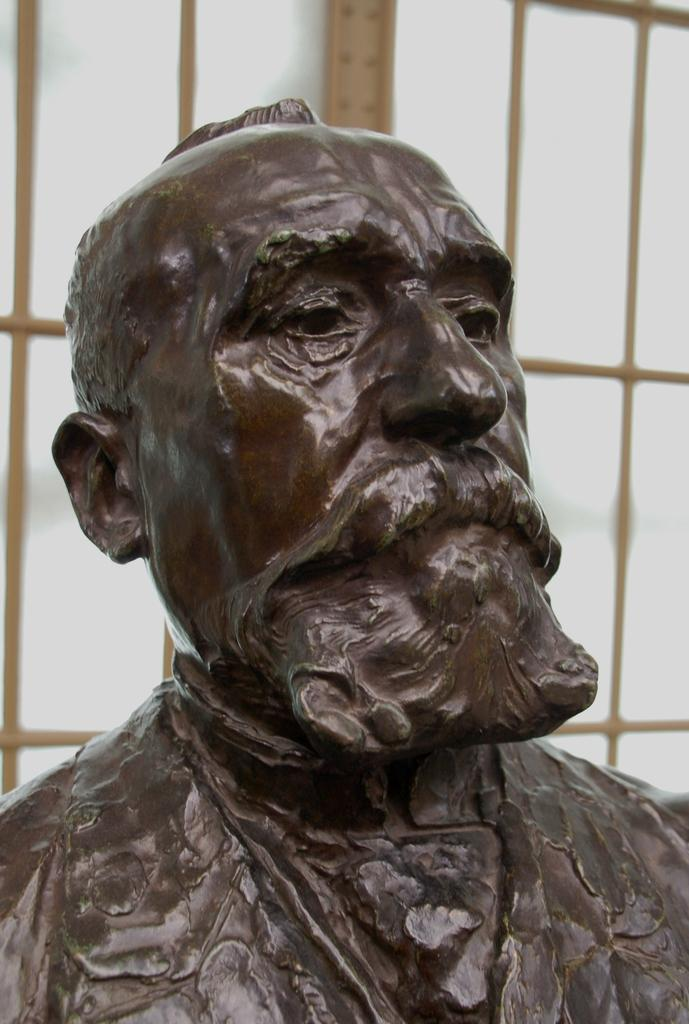What is the main subject in the center of the image? There is a statue in the center of the image. What can be seen in the background of the image? There is a window in the background of the image. What type of wound is visible on the statue in the image? There is no wound visible on the statue in the image. What type of operation is being performed on the statue in the image? There is no operation being performed on the statue in the image. 